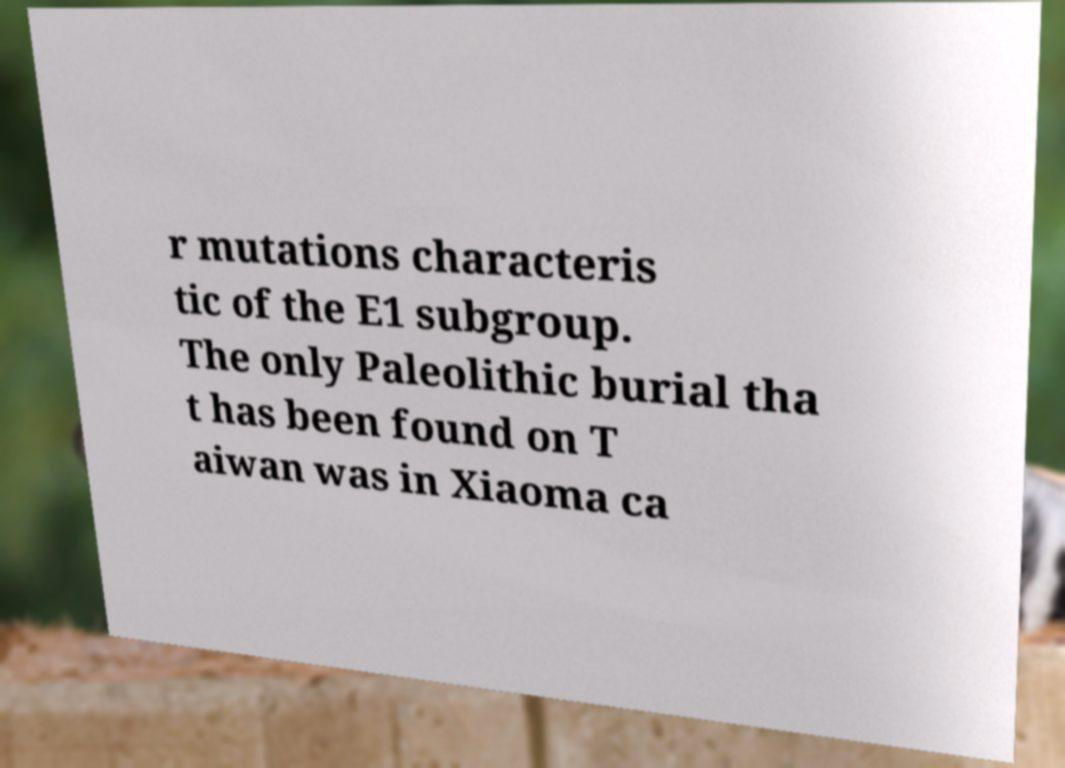Please read and relay the text visible in this image. What does it say? r mutations characteris tic of the E1 subgroup. The only Paleolithic burial tha t has been found on T aiwan was in Xiaoma ca 